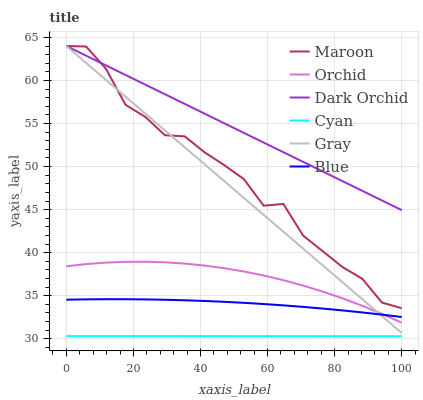Does Cyan have the minimum area under the curve?
Answer yes or no. Yes. Does Dark Orchid have the maximum area under the curve?
Answer yes or no. Yes. Does Gray have the minimum area under the curve?
Answer yes or no. No. Does Gray have the maximum area under the curve?
Answer yes or no. No. Is Dark Orchid the smoothest?
Answer yes or no. Yes. Is Maroon the roughest?
Answer yes or no. Yes. Is Gray the smoothest?
Answer yes or no. No. Is Gray the roughest?
Answer yes or no. No. Does Cyan have the lowest value?
Answer yes or no. Yes. Does Gray have the lowest value?
Answer yes or no. No. Does Maroon have the highest value?
Answer yes or no. Yes. Does Cyan have the highest value?
Answer yes or no. No. Is Blue less than Maroon?
Answer yes or no. Yes. Is Blue greater than Cyan?
Answer yes or no. Yes. Does Gray intersect Blue?
Answer yes or no. Yes. Is Gray less than Blue?
Answer yes or no. No. Is Gray greater than Blue?
Answer yes or no. No. Does Blue intersect Maroon?
Answer yes or no. No. 